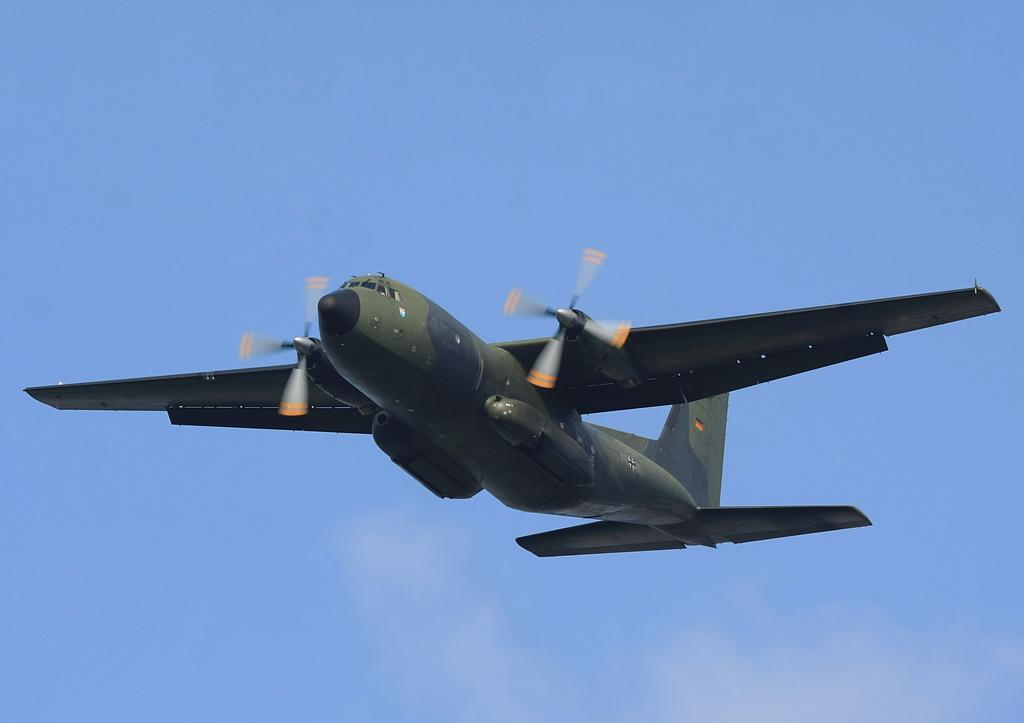What is the main subject of the image? The main subject of the image is an airplane flying in the air. What is the color of the sky in the image? The sky is blue in the image. Are there any other weather elements visible in the sky? Yes, there are clouds in the sky in the image. How many people are in the crowd gathered around the airplane in the image? There is no crowd present in the image; it only shows an airplane flying in the sky. What time of day is depicted in the image? The time of day cannot be determined from the image, as there are no specific indicators of time. 